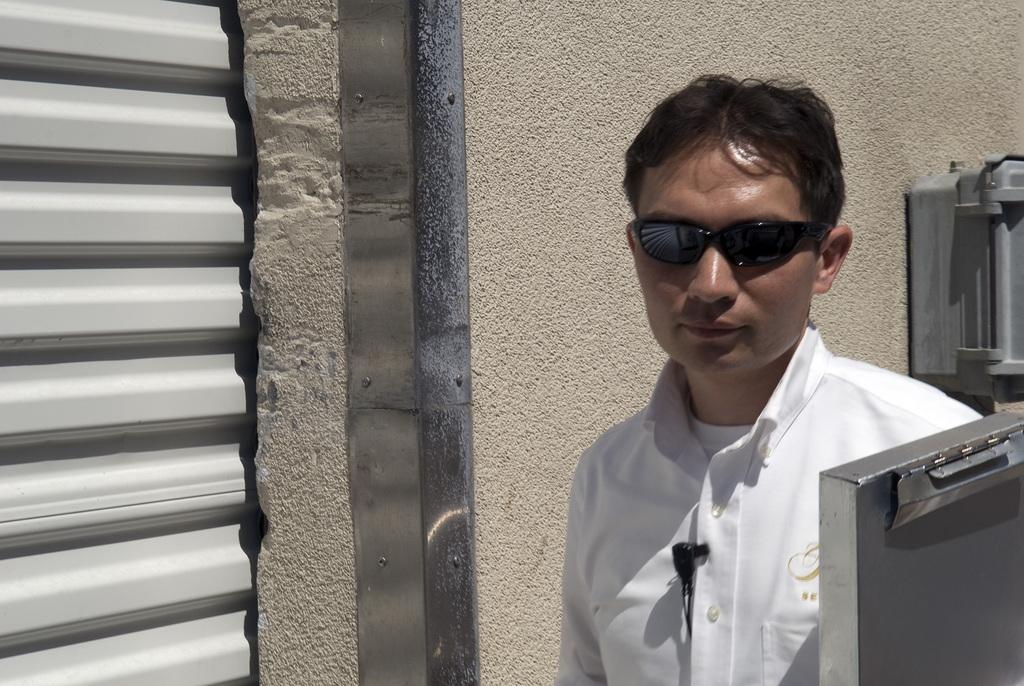Who is present in the image? There is a man in the image. What is the man wearing on his face? The man is wearing goggles. What can be seen in the background of the image? There is a wall in the background of the image. How does the man's stomach feel in the image? There is no information about the man's stomach in the image, so it cannot be determined how he feels. 